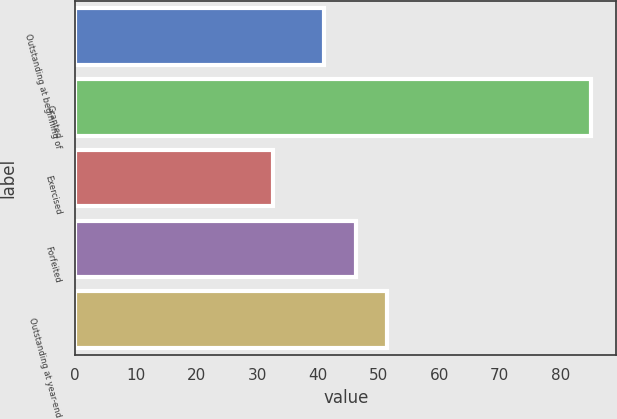<chart> <loc_0><loc_0><loc_500><loc_500><bar_chart><fcel>Outstanding at beginning of<fcel>Granted<fcel>Exercised<fcel>Forfeited<fcel>Outstanding at year-end<nl><fcel>41.02<fcel>84.95<fcel>32.69<fcel>46.25<fcel>51.48<nl></chart> 